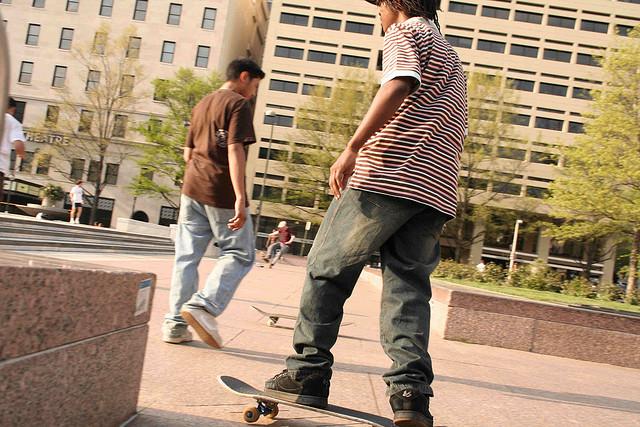Are the skateboarders on the same level as the street?
Quick response, please. Yes. Are the skateboarders wearing helmets?
Keep it brief. No. Is this blurry photo?
Short answer required. No. How many windows?
Quick response, please. 75. Is it sunny?
Concise answer only. Yes. Is the man scared that the kid will fall into the water?
Concise answer only. No. Is this a commercial or residential area?
Quick response, please. Commercial. 